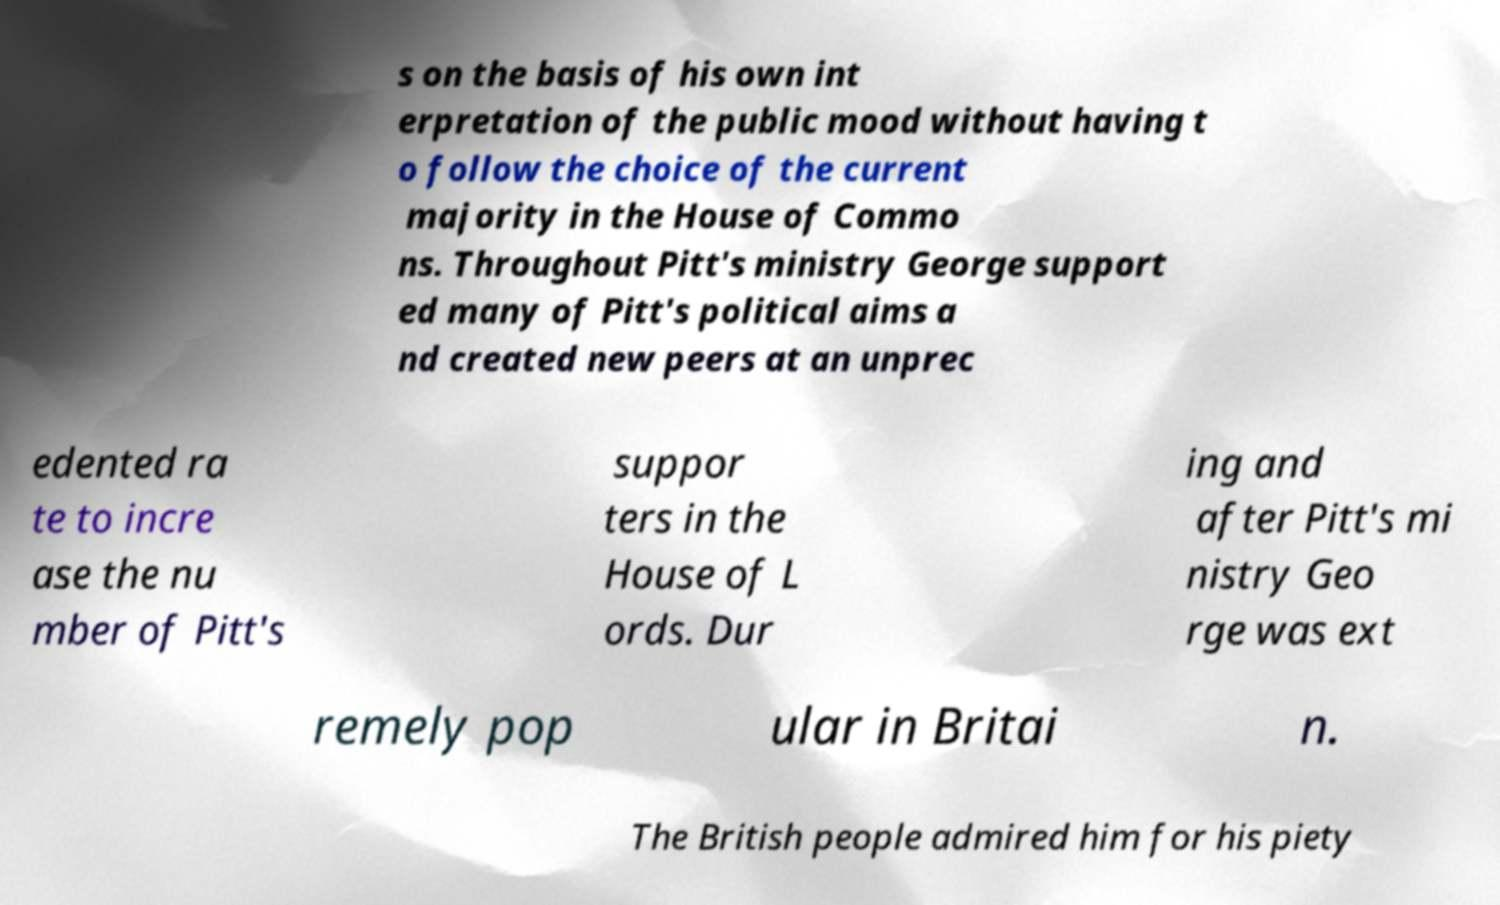Can you accurately transcribe the text from the provided image for me? s on the basis of his own int erpretation of the public mood without having t o follow the choice of the current majority in the House of Commo ns. Throughout Pitt's ministry George support ed many of Pitt's political aims a nd created new peers at an unprec edented ra te to incre ase the nu mber of Pitt's suppor ters in the House of L ords. Dur ing and after Pitt's mi nistry Geo rge was ext remely pop ular in Britai n. The British people admired him for his piety 